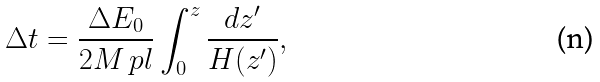Convert formula to latex. <formula><loc_0><loc_0><loc_500><loc_500>\Delta t = \frac { \Delta E _ { 0 } } { 2 M _ { \ } p l } \int _ { 0 } ^ { z } \frac { d z ^ { \prime } } { H ( z ^ { \prime } ) } ,</formula> 